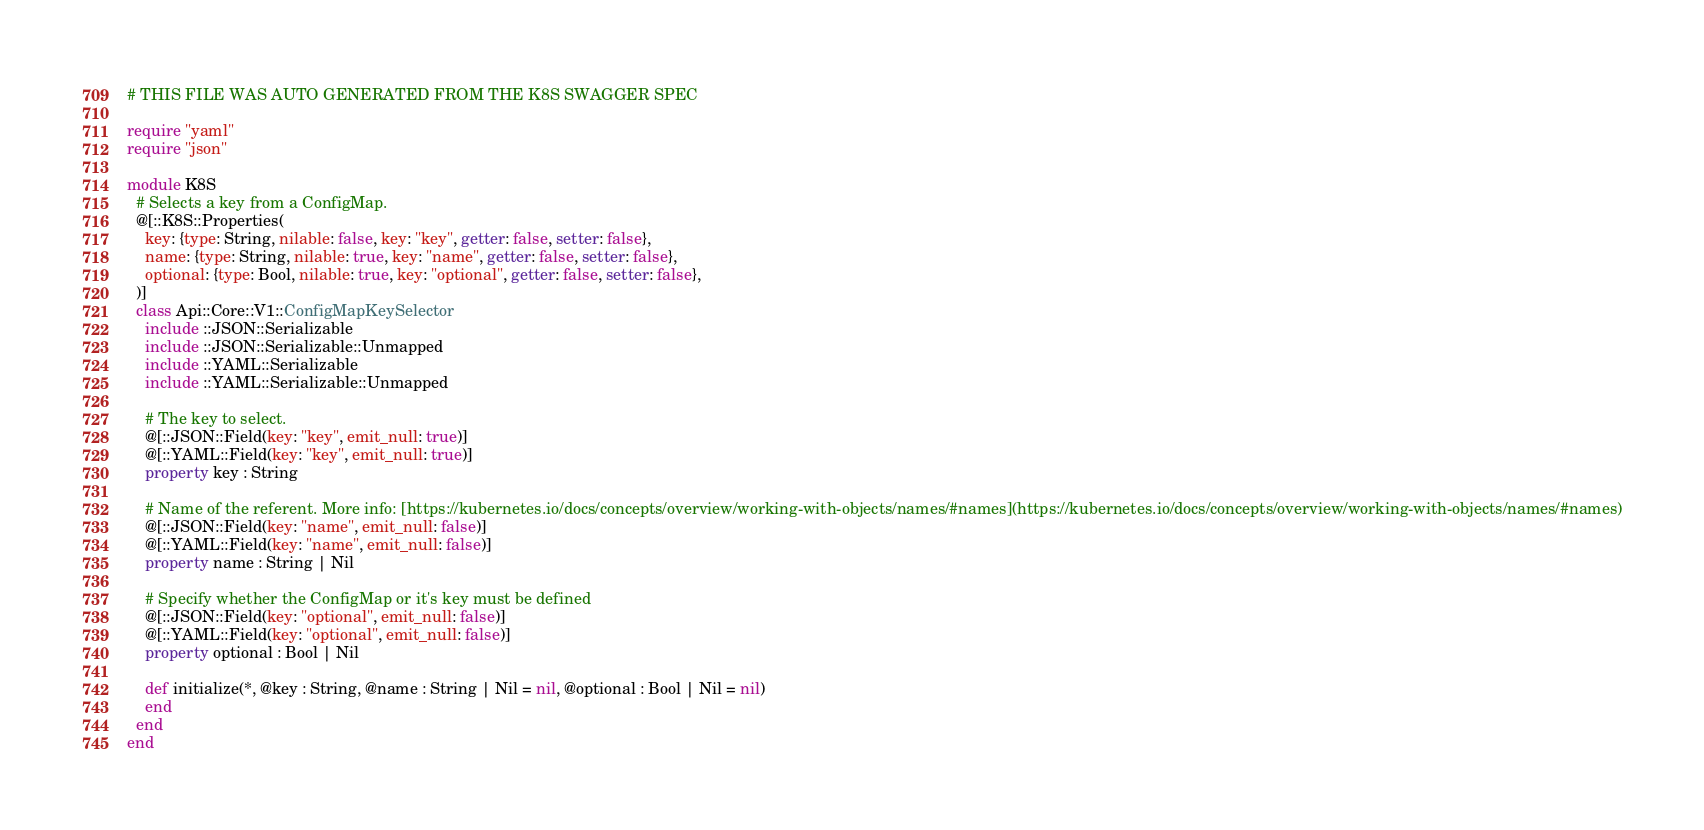Convert code to text. <code><loc_0><loc_0><loc_500><loc_500><_Crystal_># THIS FILE WAS AUTO GENERATED FROM THE K8S SWAGGER SPEC

require "yaml"
require "json"

module K8S
  # Selects a key from a ConfigMap.
  @[::K8S::Properties(
    key: {type: String, nilable: false, key: "key", getter: false, setter: false},
    name: {type: String, nilable: true, key: "name", getter: false, setter: false},
    optional: {type: Bool, nilable: true, key: "optional", getter: false, setter: false},
  )]
  class Api::Core::V1::ConfigMapKeySelector
    include ::JSON::Serializable
    include ::JSON::Serializable::Unmapped
    include ::YAML::Serializable
    include ::YAML::Serializable::Unmapped

    # The key to select.
    @[::JSON::Field(key: "key", emit_null: true)]
    @[::YAML::Field(key: "key", emit_null: true)]
    property key : String

    # Name of the referent. More info: [https://kubernetes.io/docs/concepts/overview/working-with-objects/names/#names](https://kubernetes.io/docs/concepts/overview/working-with-objects/names/#names)
    @[::JSON::Field(key: "name", emit_null: false)]
    @[::YAML::Field(key: "name", emit_null: false)]
    property name : String | Nil

    # Specify whether the ConfigMap or it's key must be defined
    @[::JSON::Field(key: "optional", emit_null: false)]
    @[::YAML::Field(key: "optional", emit_null: false)]
    property optional : Bool | Nil

    def initialize(*, @key : String, @name : String | Nil = nil, @optional : Bool | Nil = nil)
    end
  end
end
</code> 